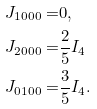<formula> <loc_0><loc_0><loc_500><loc_500>J _ { 1 0 0 0 } = & 0 , \\ J _ { 2 0 0 0 } = & \frac { 2 } { 5 } I _ { 4 } \\ J _ { 0 1 0 0 } = & \frac { 3 } { 5 } I _ { 4 } .</formula> 